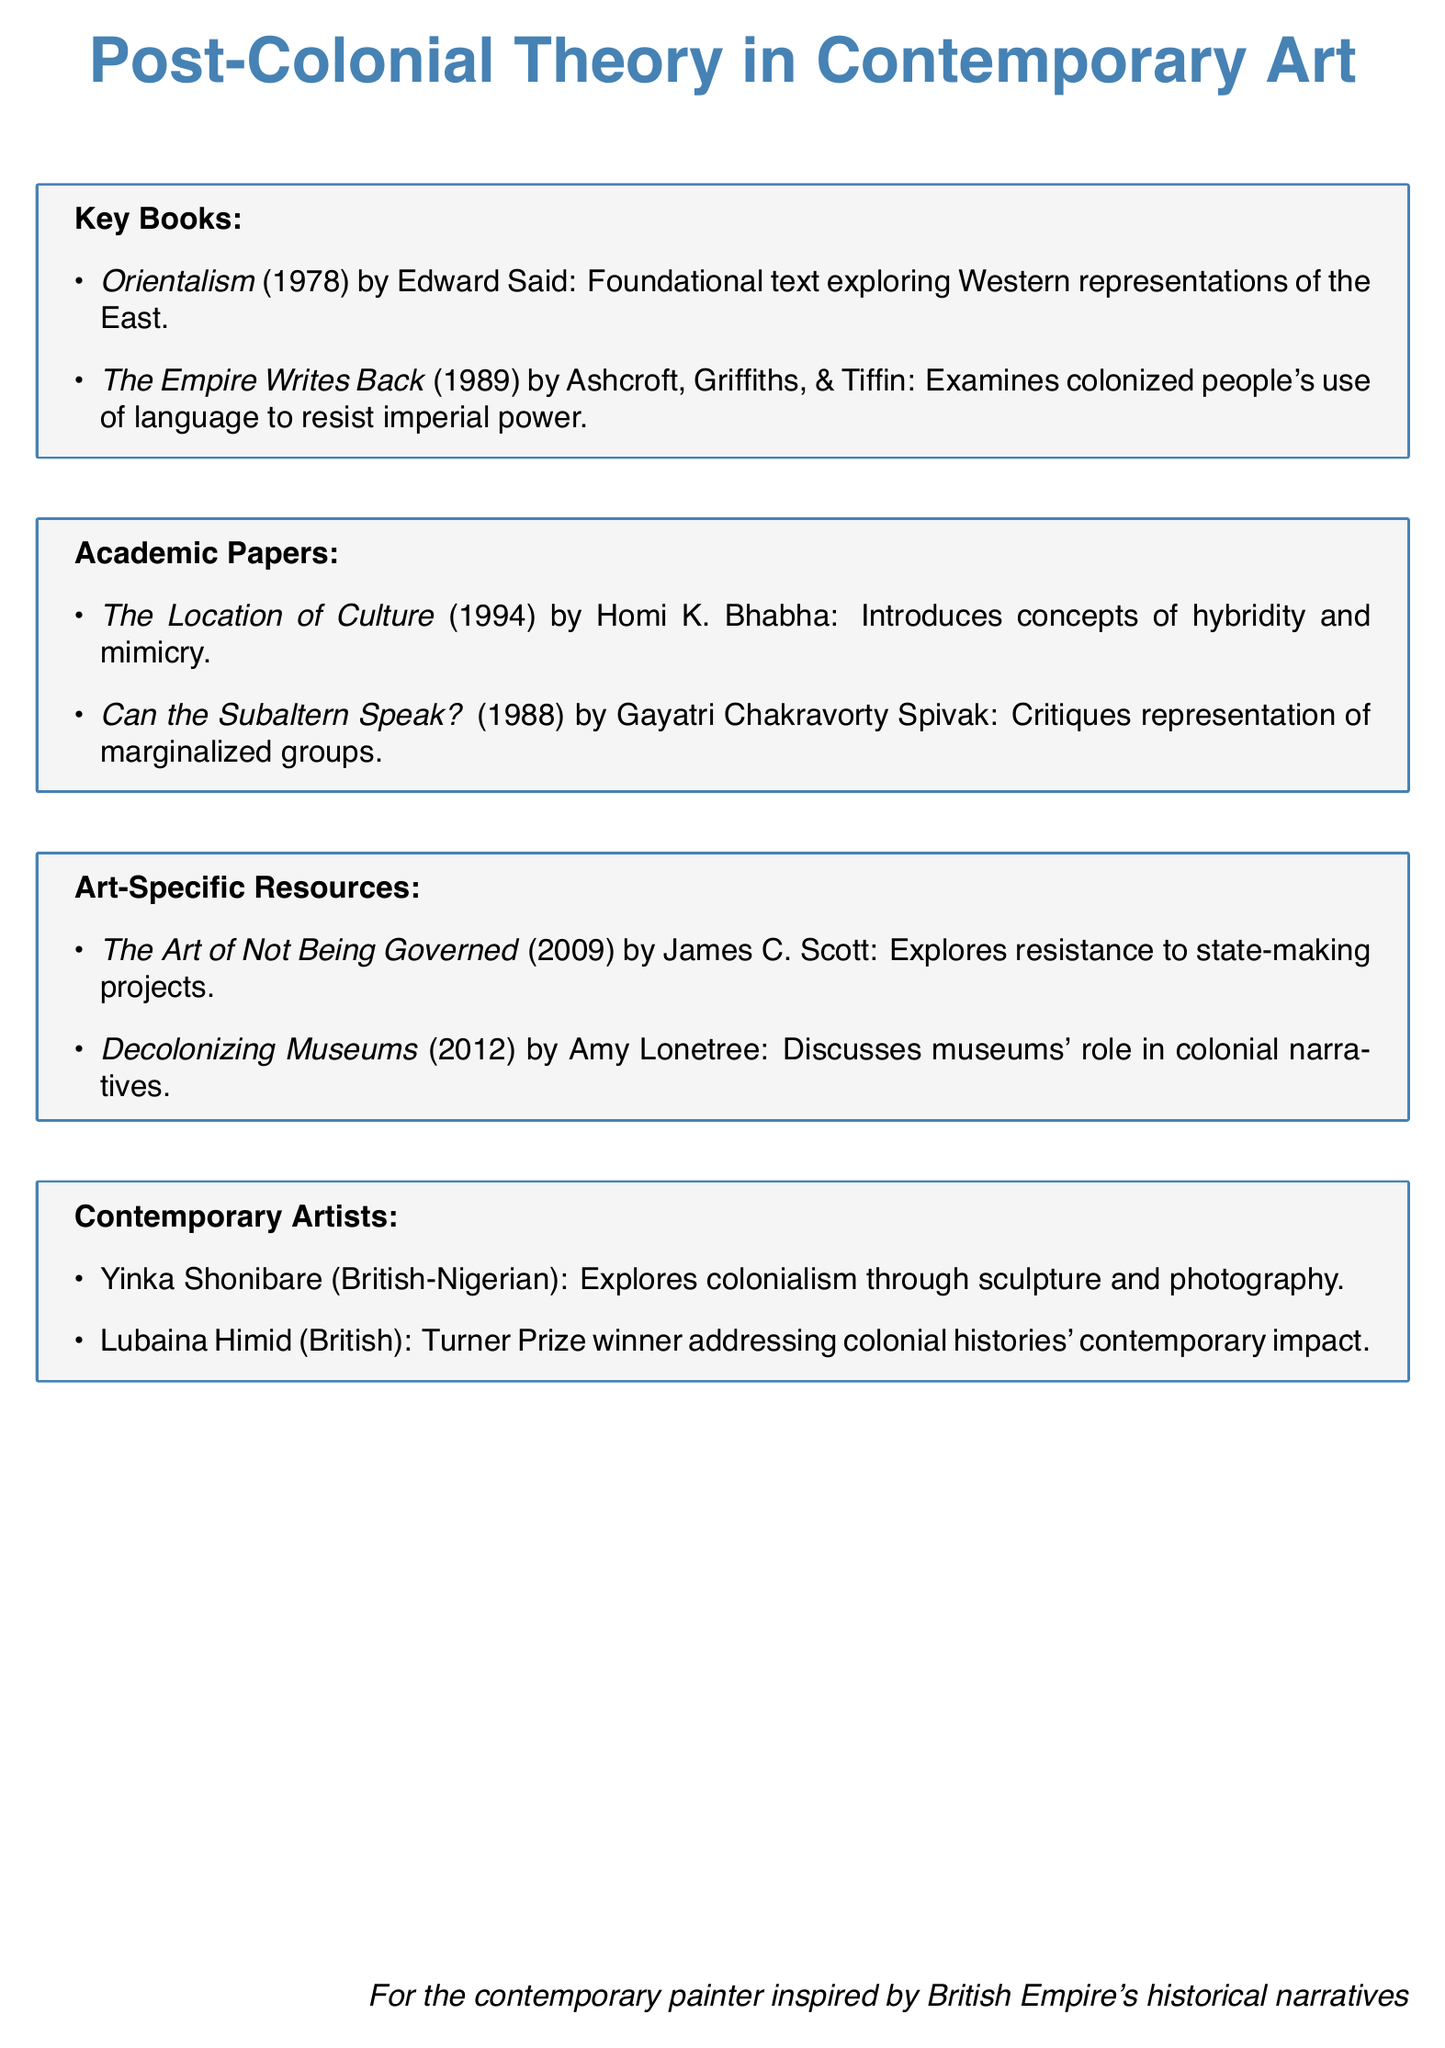What is the title of the foundational text by Edward Said? The document lists "Orientalism" as the foundational text by Edward Said.
Answer: Orientalism Who are the authors of "The Empire Writes Back"? The document states that the authors of "The Empire Writes Back" are Bill Ashcroft, Gareth Griffiths, and Helen Tiffin.
Answer: Bill Ashcroft, Gareth Griffiths, Helen Tiffin What year was "Can the Subaltern Speak?" published? The document mentions that "Can the Subaltern Speak?" was published in 1988.
Answer: 1988 What concept does Homi K. Bhabha introduce in his paper? According to the document, Homi K. Bhabha introduces the concepts of hybridity and mimicry in his paper.
Answer: Hybridity and mimicry Which artist is known for exploring colonialism through sculpture and photography? The document highlights Yinka Shonibare as the artist known for exploring colonialism through sculpture and photography.
Answer: Yinka Shonibare What is the main focus of Amy Lonetree's book? The document indicates that Amy Lonetree's book discusses the role of museums in perpetuating or challenging colonial narratives.
Answer: Museums in colonial narratives What is the nationality of Lubaina Himid? The document states that Lubaina Himid is British.
Answer: British In what year did James C. Scott publish "The Art of Not Being Governed"? The document provides the publication year of "The Art of Not Being Governed" as 2009.
Answer: 2009 